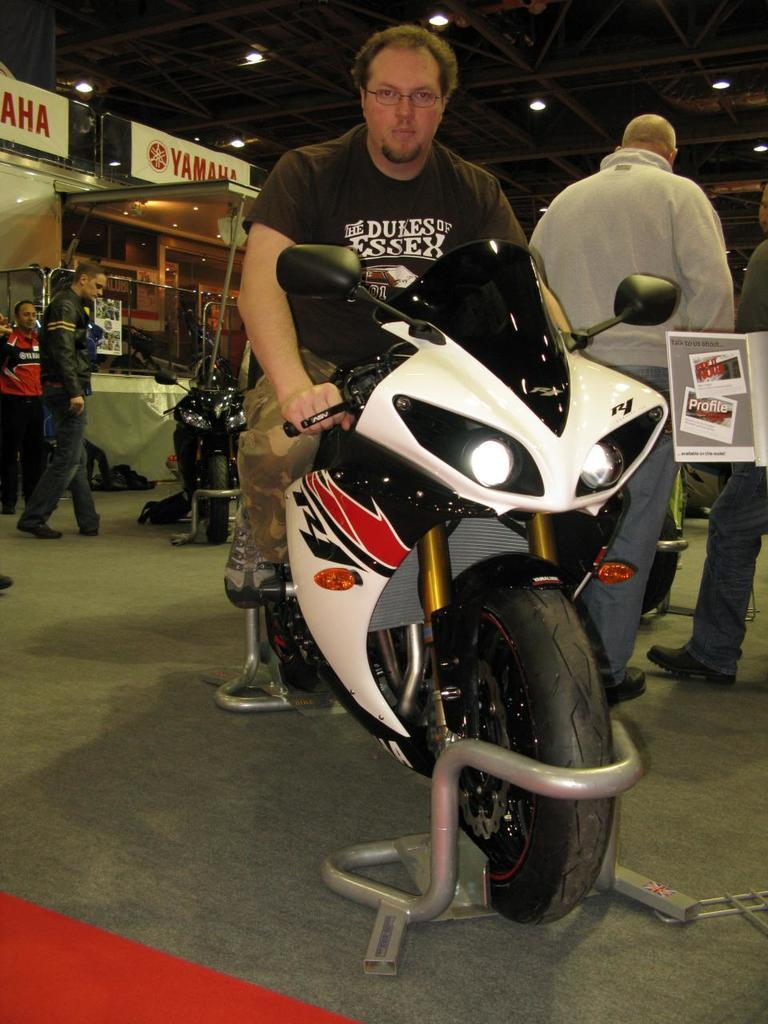What is the man in the image doing? The man is sitting on a bike in the image. What can be seen in the background of the image? There are people standing and a wall visible in the background of the image. What else is present in the background of the image? There are lights and vehicles visible in the background of the image. What type of voice can be heard coming from the representative in the image? There is no representative present in the image, and therefore no voice can be heard. 